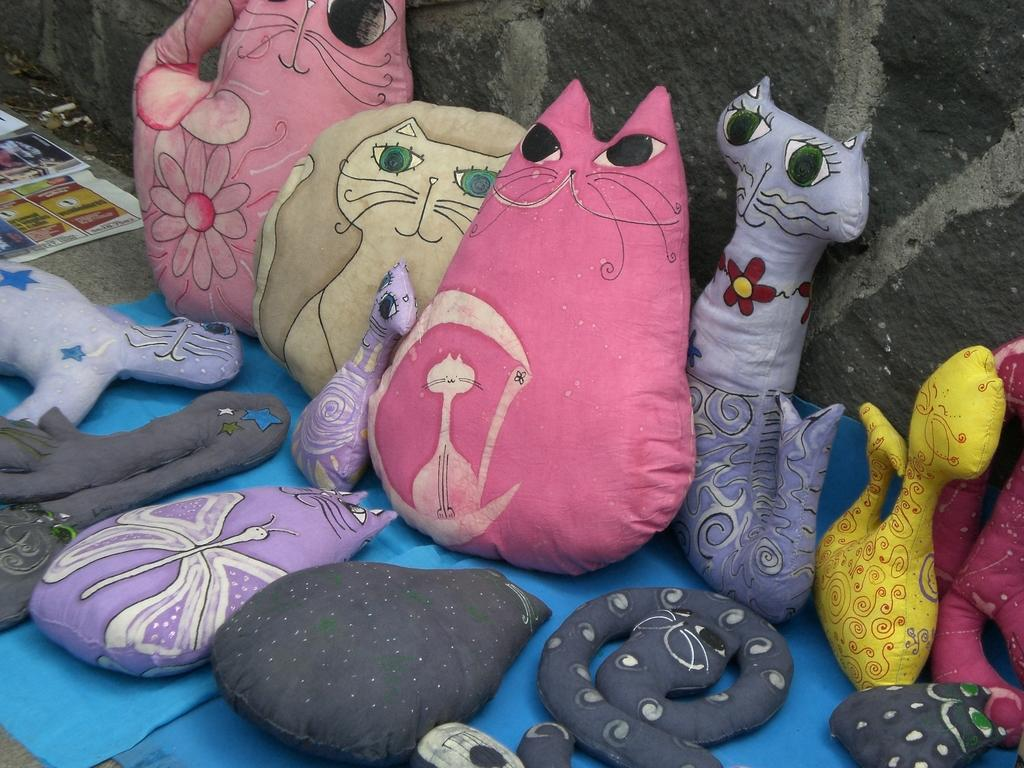What is the main subject in the center of the image? There are soft toys in the center of the image. What can be seen in the background of the image? There is a wall in the background of the image. Where is the paper located in the image? The paper is to the left side of the image. What type of cart is being used to transport the soft toys in the image? There is no cart present in the image; the soft toys are simply placed in the center. 